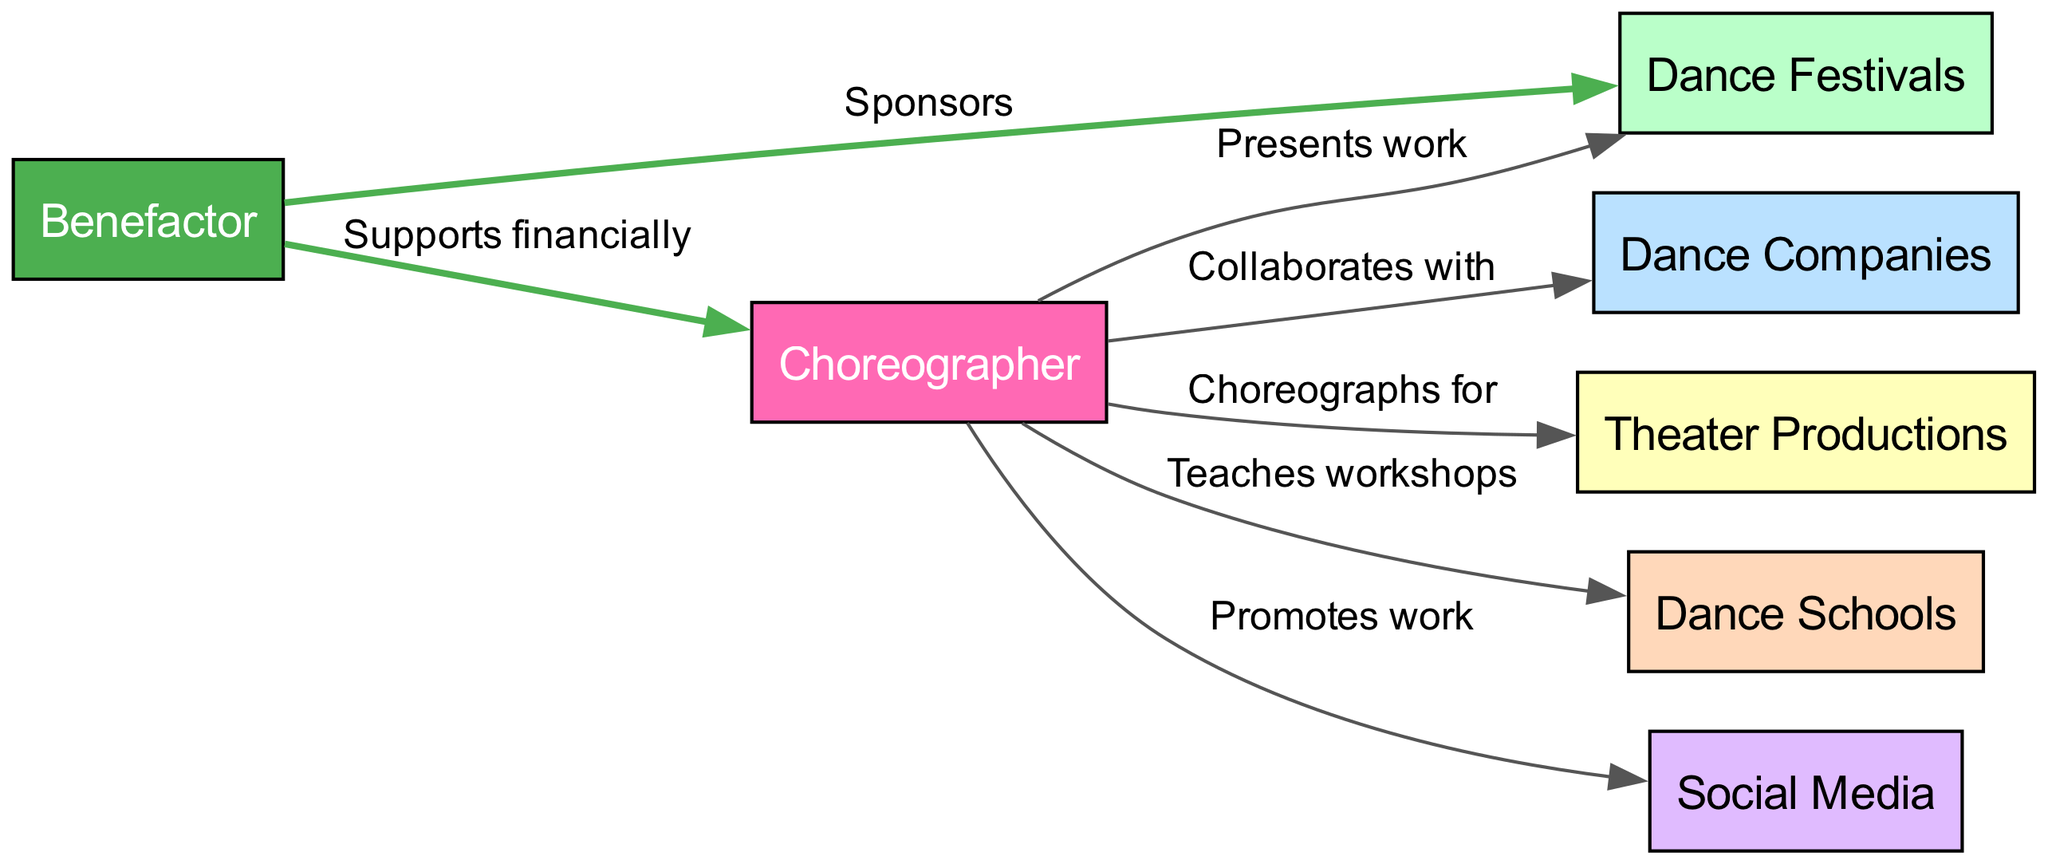What is the central node in the diagram? The central node in the diagram is identified as "Choreographer," which is the only node without any incoming edges, making it the focus of the network.
Answer: Choreographer How many nodes are in the diagram? To determine the number of nodes, we can count the unique entities listed in the diagram. There are six distinct nodes apart from the Choreographer. Thus, the total is 7.
Answer: 7 List a node that the Choreographer collaborates with. By reviewing the outgoing edges from the Choreographer, we see "Dance Companies" is directly mentioned as a collaborator, making it a valid answer.
Answer: Dance Companies What role does the Benefactor play in the Choreographer's career? The diagram shows a direct edge from the Benefactor to the Choreographer labeled "Supports financially," indicating that the benefactor provides financial assistance, which is crucial for the choreographer's activities.
Answer: Supports financially Which node is connected to both the Choreographer and Dance Festivals? The edge from the Choreographer to the Dance Festivals, along with the edge from the Benefactor to the Dance Festivals, suggests a connection. However, in terms of direct interaction, the Benefactor is the common node linked to both other entities, showing their mutual relationship with the Choreographer.
Answer: Benefactor What opportunity arises from the relationship between the Choreographer and Dance Schools? The edge labeled "Teaches workshops" indicates that the Choreographer uses Dance Schools as an avenue to educate and collaborate, creating a valuable opportunity for sharing expertise.
Answer: Teaches workshops How are social media and the Choreographer connected? The edge connects the Choreographer with "Social Media," labeled "Promotes work." This illustrates that the Choreographer utilizes social media platforms, like Instagram or Facebook, to showcase artistic creations and reach a broader audience.
Answer: Promotes work What type of productions does the Choreographer contribute to? The diagram specifies that the Choreographer "Choreographs for" Theater Productions, indicating their involvement in this essential aspect of the arts.
Answer: Theater Productions Which node can be considered a source of sponsorship for the Dance Festivals? The edge shows that the Benefactor has a direct relationship with Dance Festivals labeled "Sponsors," making the Benefactor the source of sponsorship for these events.
Answer: Sponsors 